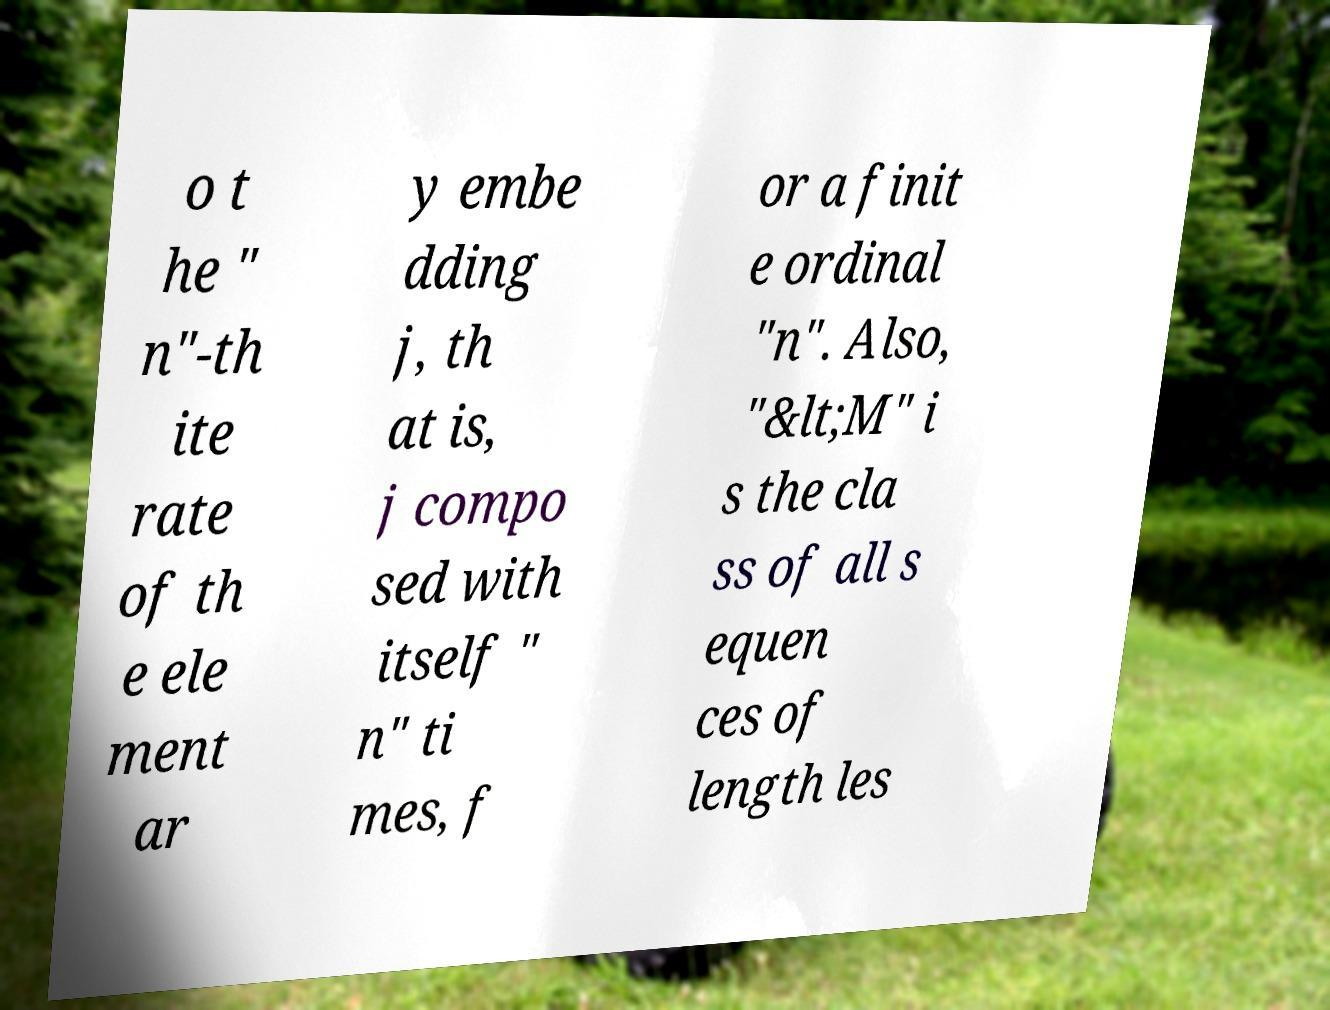Can you accurately transcribe the text from the provided image for me? o t he " n"-th ite rate of th e ele ment ar y embe dding j, th at is, j compo sed with itself " n" ti mes, f or a finit e ordinal "n". Also, "&lt;M" i s the cla ss of all s equen ces of length les 